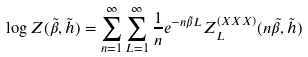Convert formula to latex. <formula><loc_0><loc_0><loc_500><loc_500>\log Z ( \tilde { \beta } , \tilde { h } ) = \sum _ { n = 1 } ^ { \infty } \sum _ { L = 1 } ^ { \infty } \frac { 1 } { n } e ^ { - n \tilde { \beta } L } Z _ { L } ^ { ( X X X ) } ( n \tilde { \beta } , \tilde { h } )</formula> 